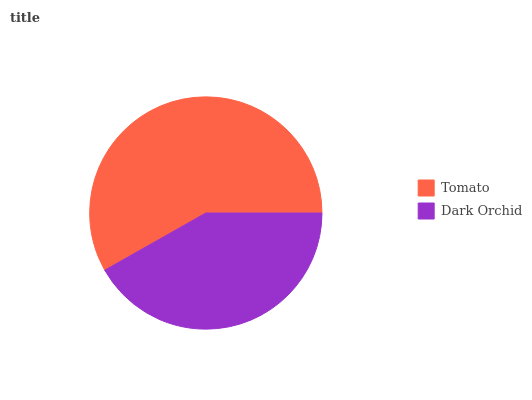Is Dark Orchid the minimum?
Answer yes or no. Yes. Is Tomato the maximum?
Answer yes or no. Yes. Is Dark Orchid the maximum?
Answer yes or no. No. Is Tomato greater than Dark Orchid?
Answer yes or no. Yes. Is Dark Orchid less than Tomato?
Answer yes or no. Yes. Is Dark Orchid greater than Tomato?
Answer yes or no. No. Is Tomato less than Dark Orchid?
Answer yes or no. No. Is Tomato the high median?
Answer yes or no. Yes. Is Dark Orchid the low median?
Answer yes or no. Yes. Is Dark Orchid the high median?
Answer yes or no. No. Is Tomato the low median?
Answer yes or no. No. 